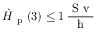Convert formula to latex. <formula><loc_0><loc_0><loc_500><loc_500>\ D o t { H } _ { p } ( 3 ) \leq 1 \, \frac { S v } { h }</formula> 